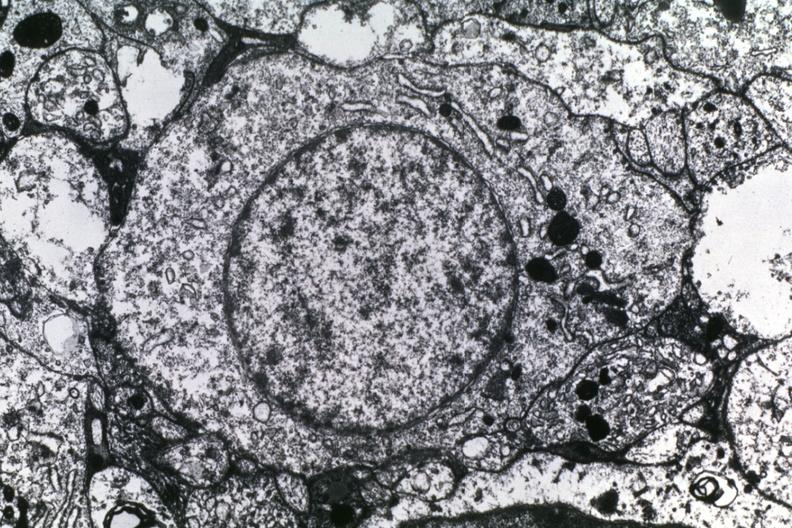what is present?
Answer the question using a single word or phrase. Brain 